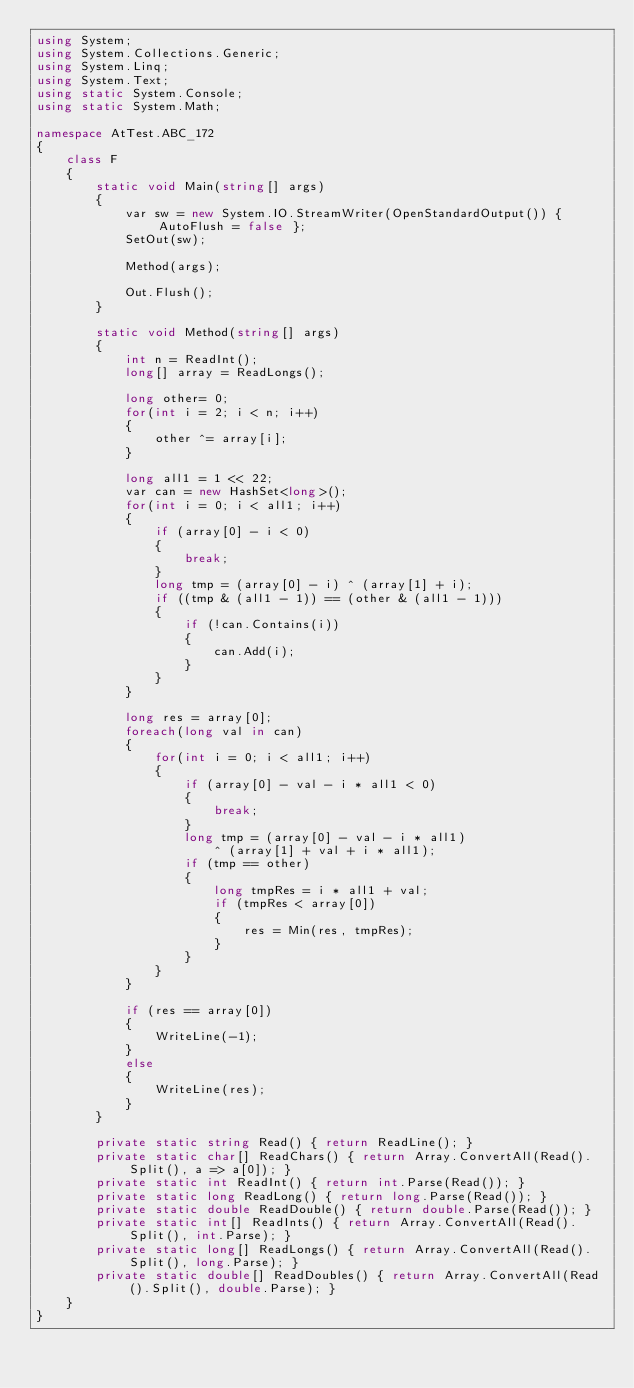<code> <loc_0><loc_0><loc_500><loc_500><_C#_>using System;
using System.Collections.Generic;
using System.Linq;
using System.Text;
using static System.Console;
using static System.Math;

namespace AtTest.ABC_172
{
    class F
    {
        static void Main(string[] args)
        {
            var sw = new System.IO.StreamWriter(OpenStandardOutput()) { AutoFlush = false };
            SetOut(sw);

            Method(args);

            Out.Flush();
        }

        static void Method(string[] args)
        {
            int n = ReadInt();
            long[] array = ReadLongs();

            long other= 0;
            for(int i = 2; i < n; i++)
            {
                other ^= array[i];
            }

            long all1 = 1 << 22;
            var can = new HashSet<long>();
            for(int i = 0; i < all1; i++)
            {
                if (array[0] - i < 0)
                {
                    break;
                }
                long tmp = (array[0] - i) ^ (array[1] + i);
                if ((tmp & (all1 - 1)) == (other & (all1 - 1)))
                {
                    if (!can.Contains(i))
                    {
                        can.Add(i);
                    }
                }
            }

            long res = array[0];
            foreach(long val in can)
            {
                for(int i = 0; i < all1; i++)
                {
                    if (array[0] - val - i * all1 < 0)
                    {
                        break;
                    }
                    long tmp = (array[0] - val - i * all1)
                        ^ (array[1] + val + i * all1);
                    if (tmp == other)
                    {
                        long tmpRes = i * all1 + val;
                        if (tmpRes < array[0])
                        {
                            res = Min(res, tmpRes);
                        }
                    }
                }
            }

            if (res == array[0])
            {
                WriteLine(-1);
            }
            else
            {
                WriteLine(res);
            }
        }

        private static string Read() { return ReadLine(); }
        private static char[] ReadChars() { return Array.ConvertAll(Read().Split(), a => a[0]); }
        private static int ReadInt() { return int.Parse(Read()); }
        private static long ReadLong() { return long.Parse(Read()); }
        private static double ReadDouble() { return double.Parse(Read()); }
        private static int[] ReadInts() { return Array.ConvertAll(Read().Split(), int.Parse); }
        private static long[] ReadLongs() { return Array.ConvertAll(Read().Split(), long.Parse); }
        private static double[] ReadDoubles() { return Array.ConvertAll(Read().Split(), double.Parse); }
    }
}
</code> 